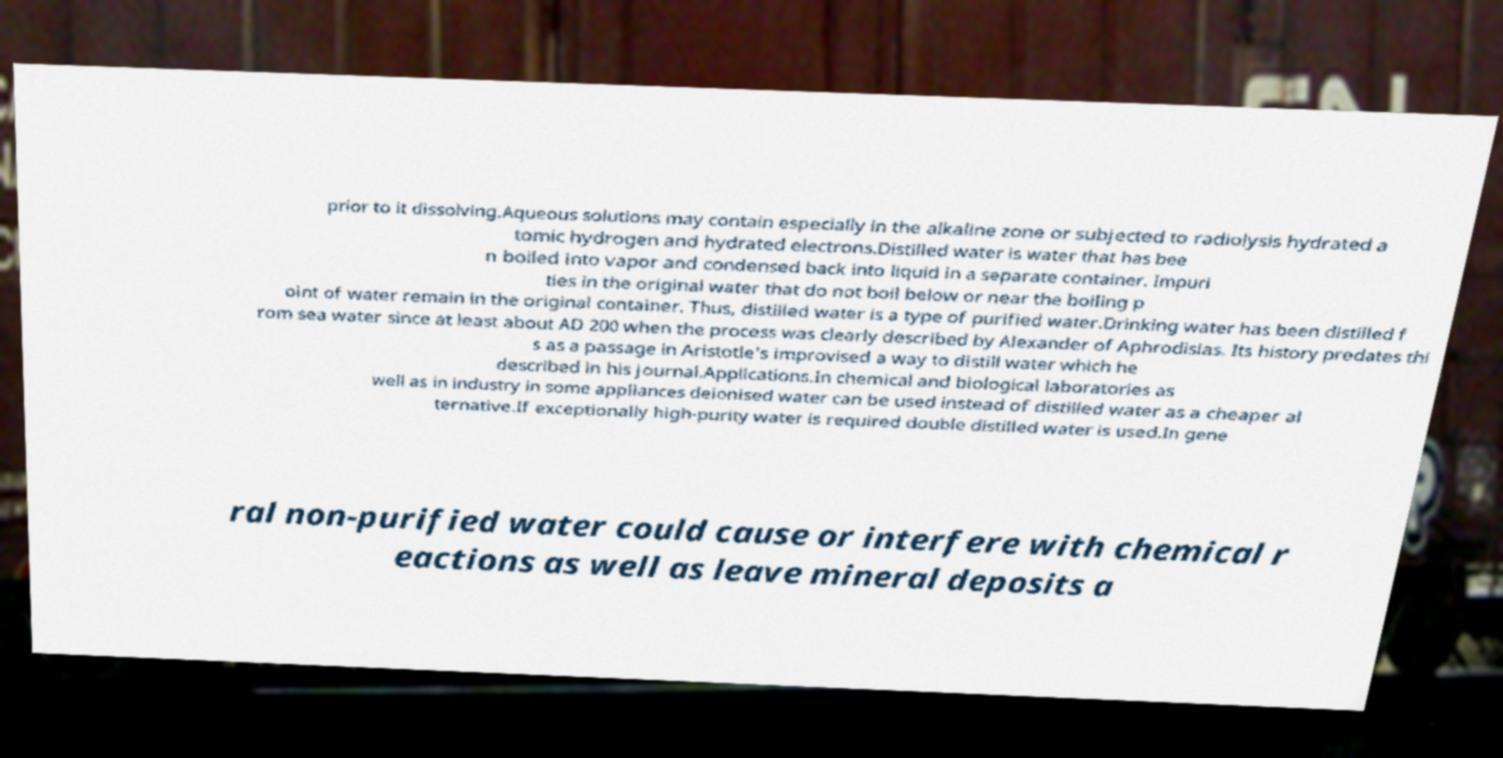Please read and relay the text visible in this image. What does it say? prior to it dissolving.Aqueous solutions may contain especially in the alkaline zone or subjected to radiolysis hydrated a tomic hydrogen and hydrated electrons.Distilled water is water that has bee n boiled into vapor and condensed back into liquid in a separate container. Impuri ties in the original water that do not boil below or near the boiling p oint of water remain in the original container. Thus, distilled water is a type of purified water.Drinking water has been distilled f rom sea water since at least about AD 200 when the process was clearly described by Alexander of Aphrodisias. Its history predates thi s as a passage in Aristotle's improvised a way to distill water which he described in his journal.Applications.In chemical and biological laboratories as well as in industry in some appliances deionised water can be used instead of distilled water as a cheaper al ternative.If exceptionally high-purity water is required double distilled water is used.In gene ral non-purified water could cause or interfere with chemical r eactions as well as leave mineral deposits a 